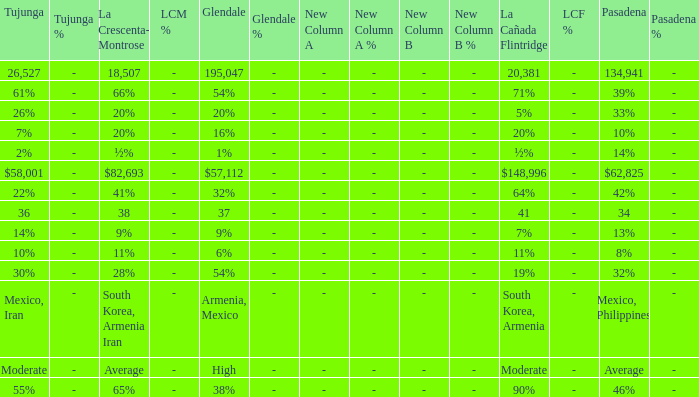What is the percentage of Tukunga when La Crescenta-Montrose is 28%? 30%. 